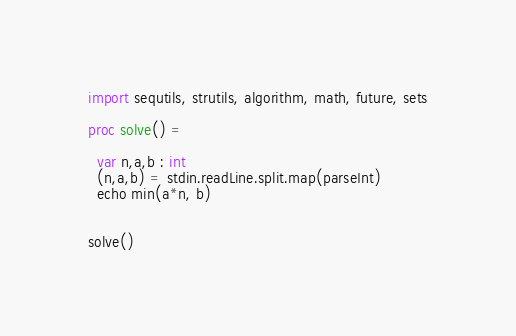<code> <loc_0><loc_0><loc_500><loc_500><_Nim_>import sequtils, strutils, algorithm, math, future, sets

proc solve() =

  var n,a,b : int
  (n,a,b) = stdin.readLine.split.map(parseInt)
  echo min(a*n, b)


solve()</code> 